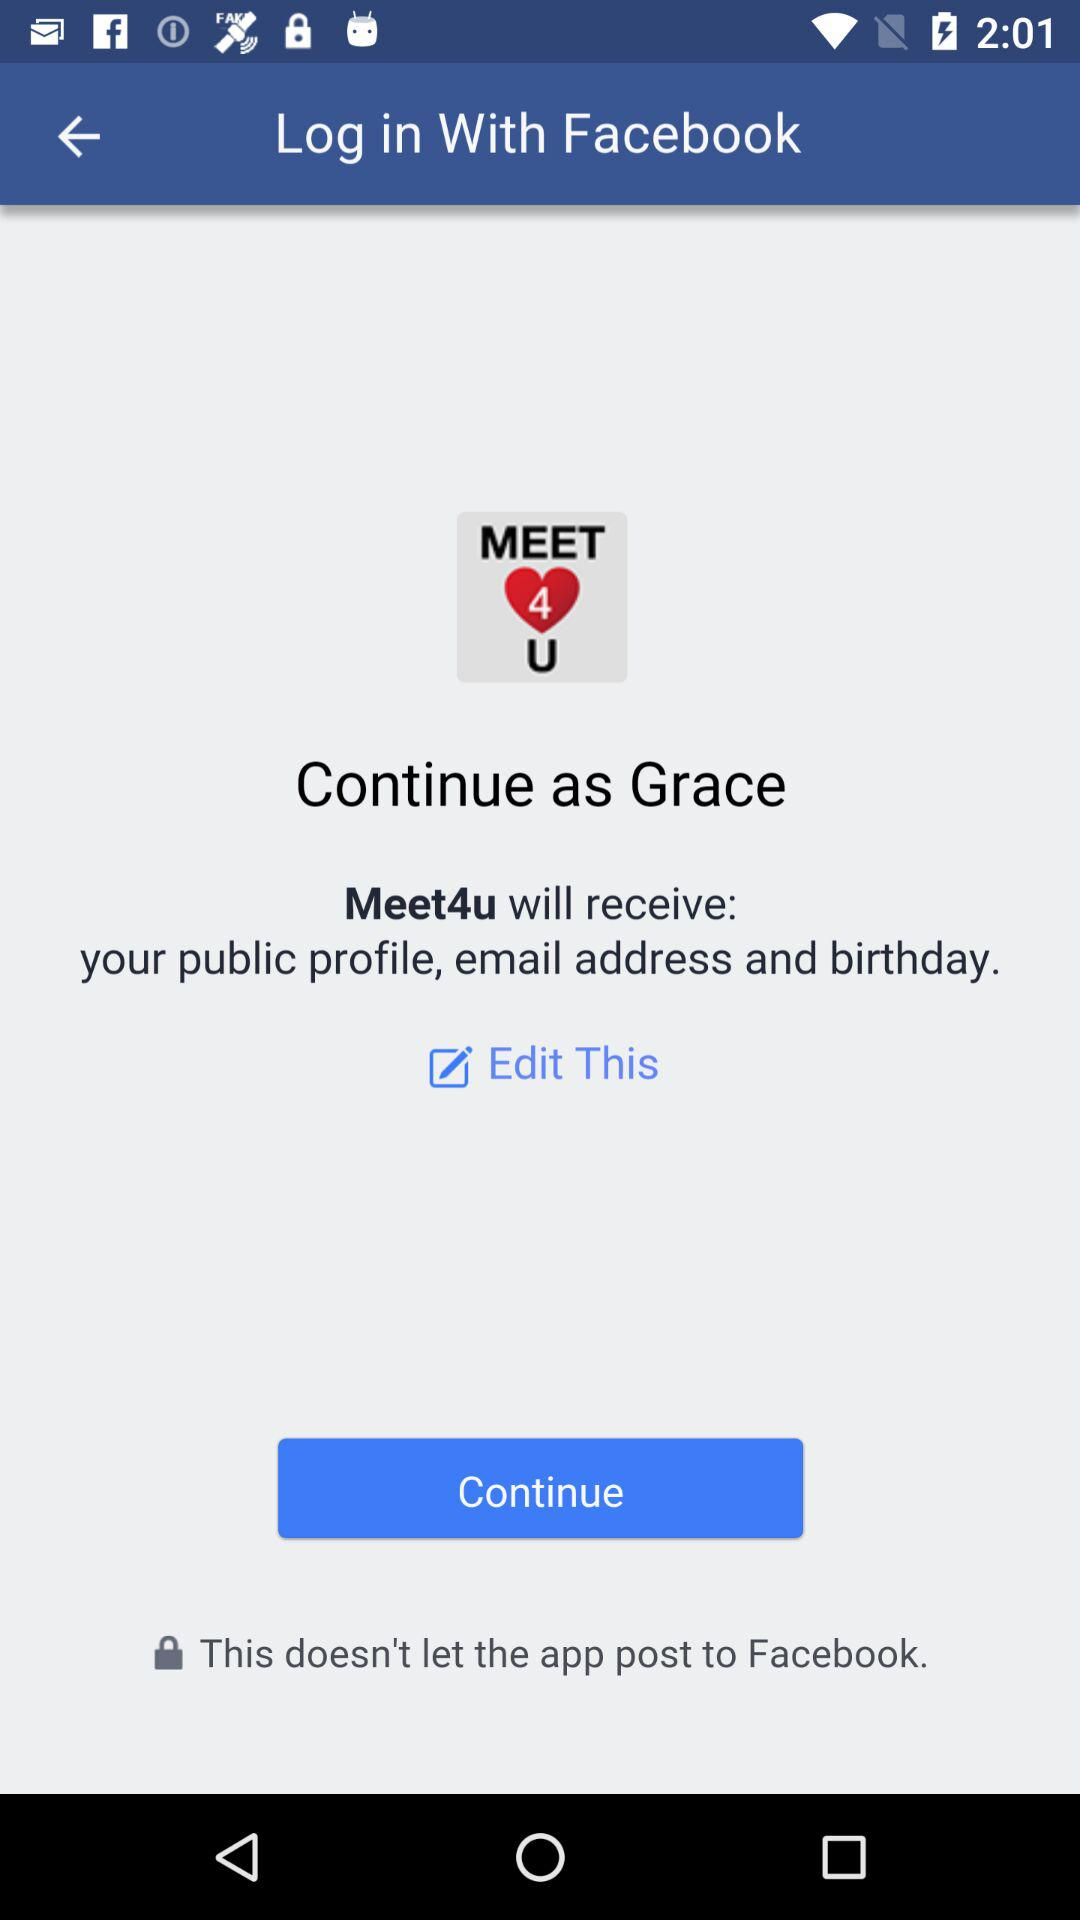What application is asking for permission? The application asking for permission is "Meet4u". 